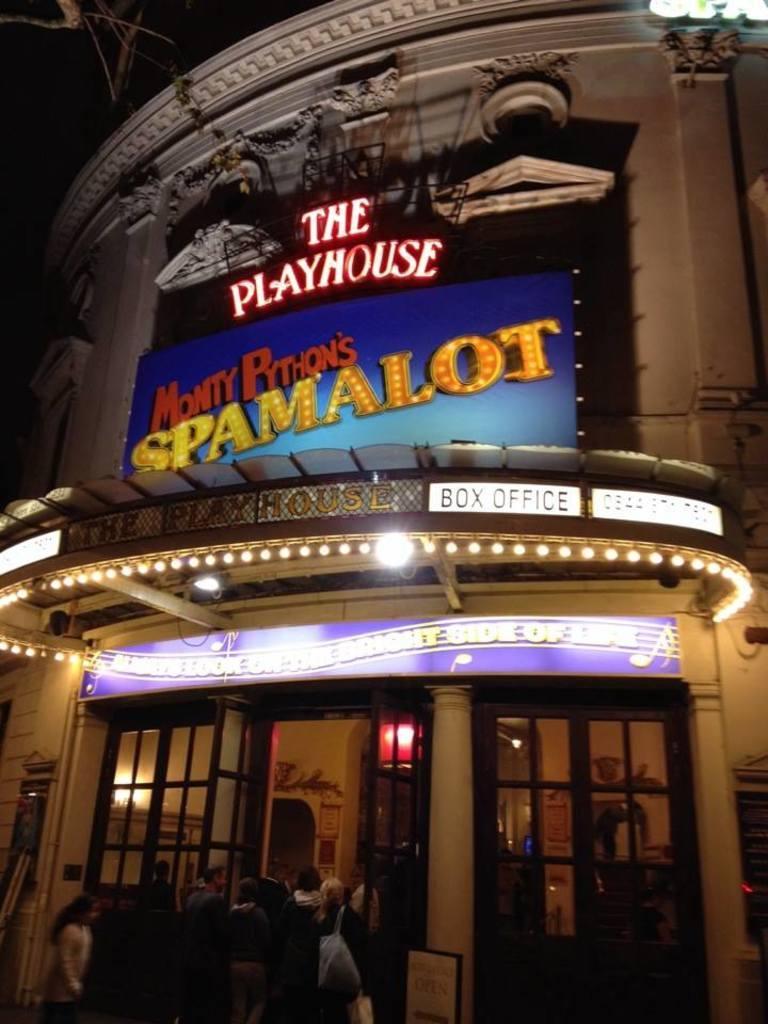Can you describe this image briefly? In this picture we can see a group of people, name boards, building, lights, windows and some objects and in the background it is dark. 